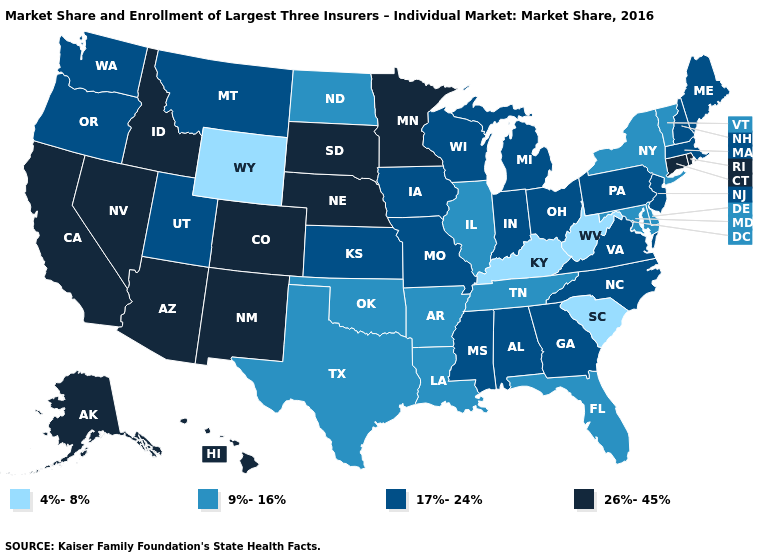What is the value of Connecticut?
Give a very brief answer. 26%-45%. What is the value of Indiana?
Quick response, please. 17%-24%. Name the states that have a value in the range 17%-24%?
Answer briefly. Alabama, Georgia, Indiana, Iowa, Kansas, Maine, Massachusetts, Michigan, Mississippi, Missouri, Montana, New Hampshire, New Jersey, North Carolina, Ohio, Oregon, Pennsylvania, Utah, Virginia, Washington, Wisconsin. Which states hav the highest value in the West?
Short answer required. Alaska, Arizona, California, Colorado, Hawaii, Idaho, Nevada, New Mexico. Name the states that have a value in the range 4%-8%?
Write a very short answer. Kentucky, South Carolina, West Virginia, Wyoming. Which states have the lowest value in the MidWest?
Be succinct. Illinois, North Dakota. Does Nevada have a lower value than North Carolina?
Give a very brief answer. No. Which states have the lowest value in the Northeast?
Write a very short answer. New York, Vermont. Which states have the lowest value in the USA?
Write a very short answer. Kentucky, South Carolina, West Virginia, Wyoming. Name the states that have a value in the range 17%-24%?
Concise answer only. Alabama, Georgia, Indiana, Iowa, Kansas, Maine, Massachusetts, Michigan, Mississippi, Missouri, Montana, New Hampshire, New Jersey, North Carolina, Ohio, Oregon, Pennsylvania, Utah, Virginia, Washington, Wisconsin. What is the value of Alaska?
Answer briefly. 26%-45%. What is the highest value in the West ?
Be succinct. 26%-45%. What is the value of Michigan?
Concise answer only. 17%-24%. Does Nevada have the lowest value in the USA?
Write a very short answer. No. Among the states that border Montana , does Idaho have the highest value?
Short answer required. Yes. 